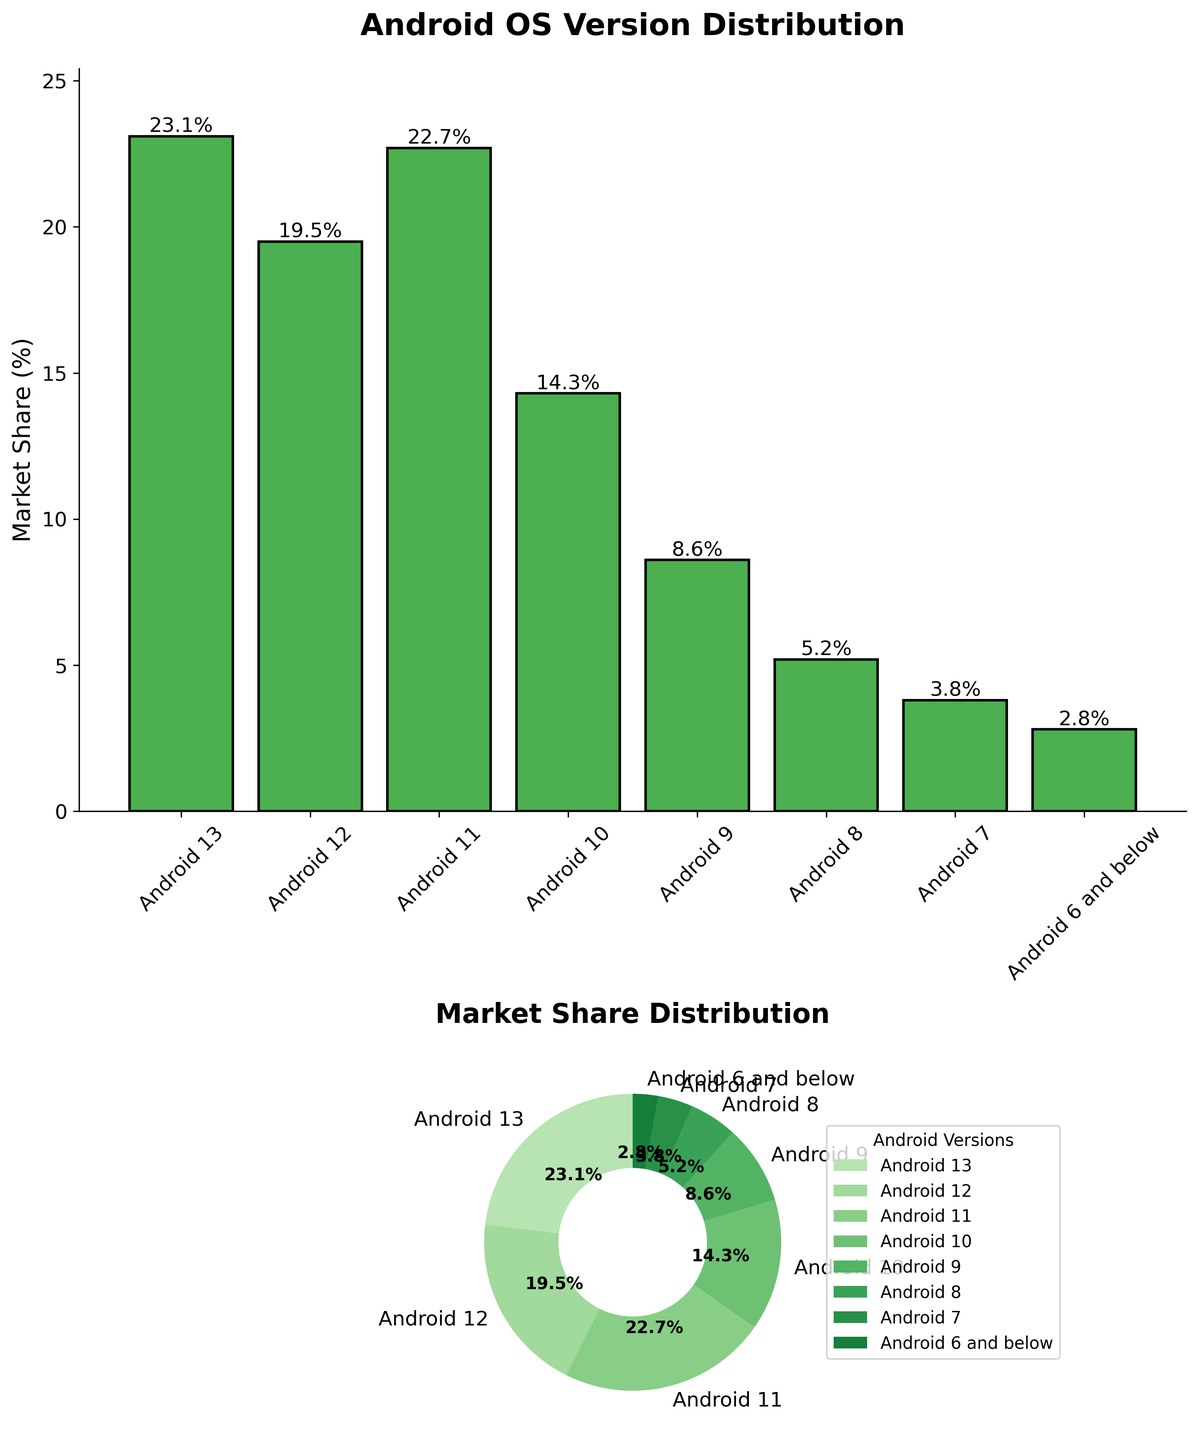How many Android OS versions are listed in the bar plot? Count the total number of bars in the bar plot. Each bar represents one Android OS version.
Answer: 8 What is the market share of Android 11? Look at the height of the bar corresponding to Android 11 in the bar plot and read the percentage value displayed above the bar.
Answer: 22.7% Which Android version has the highest market share? Identify the tallest bar in the bar plot, which corresponds to the Android version with the highest market share.
Answer: Android 13 What is the combined market share of Android 11 and Android 12? Sum the market share percentages of Android 11 (22.7%) and Android 12 (19.5%).
Answer: 42.2% Which version has a bigger market share than Android 9 but less than Android 12? Check the market share percentages of all versions. Compare them to find which one is greater than 8.6% (Android 9) but less than 19.5% (Android 12).
Answer: Android 11 What percentage of devices run versions older than Android 7? Look at the pie chart and add the percentages of versions labeled as Android 6 and below.
Answer: 2.8% Compare the market share of Android 10 and Android 11. Which one is higher and by how much? Compare the percentages of Android 10 (14.3%) and Android 11 (22.7%). Subtract the smaller percentage from the larger one.
Answer: Android 11 by 8.4% Is the market share of Android 9 higher or lower than the market share of Android 8? Compare the heights of the bars for Android 9 (8.6%) and Android 8 (5.2%) in the bar plot.
Answer: Higher What is the title of the bar plot? Read the text at the top of the bar plot.
Answer: Android OS Version Distribution In the pie chart, how many versions have a market share less than 10%? Count the segments in the pie chart that represent versions with a market share percentage less than 10%.
Answer: 4 